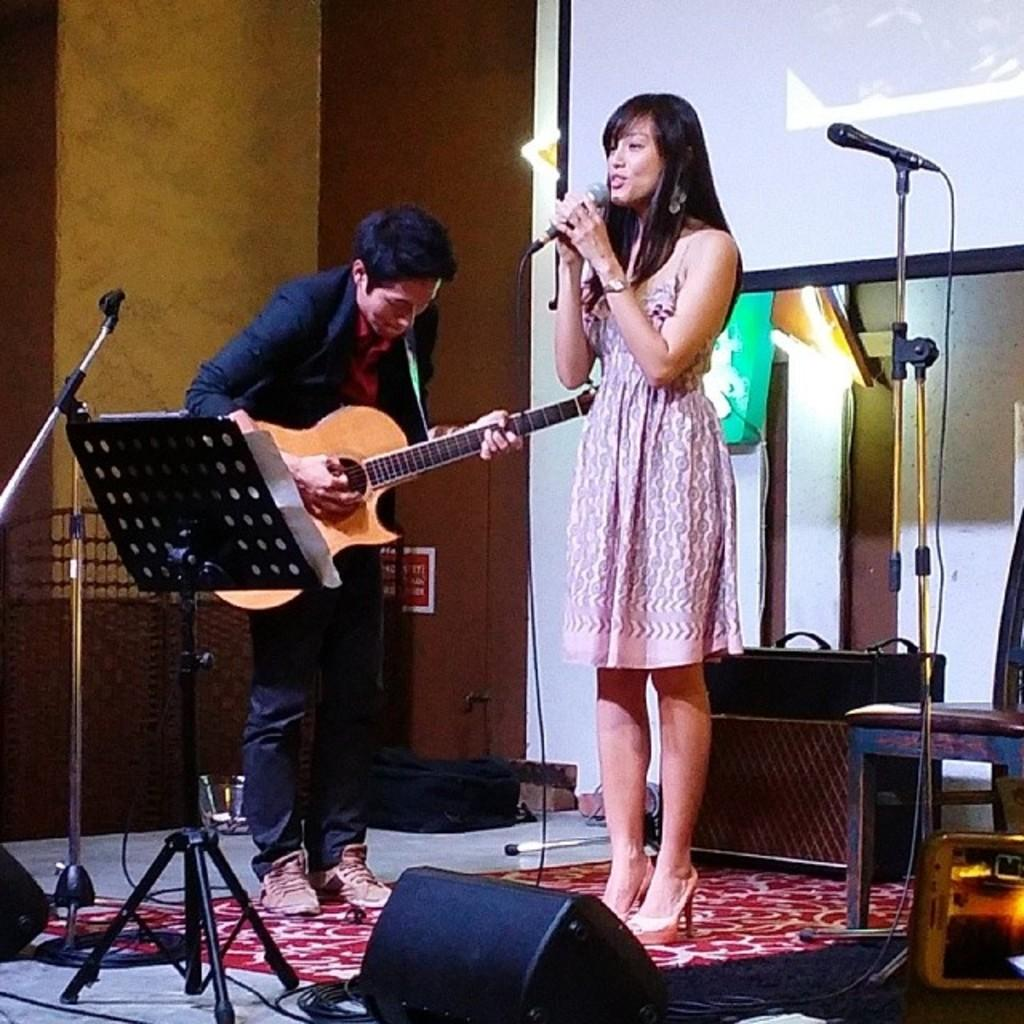How many people are in the image? There are two people in the image. What is the person on the left doing? The person on the left is playing a guitar. What is the person on the right holding? The person on the right is holding a microphone. What can be seen in the background of the image? There is a projector display visible in the background. What type of cream is being used to create the fog in the image? There is no cream or fog present in the image; it features two people, one playing a guitar and the other holding a microphone, with a projector display visible in the background. 